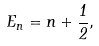<formula> <loc_0><loc_0><loc_500><loc_500>E _ { n } = n + { \frac { 1 } { 2 } } ,</formula> 